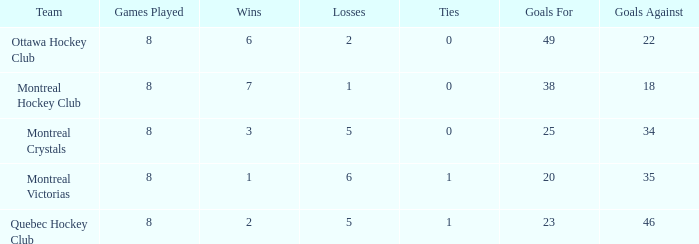What is the sum of the losses when the goals against is less than 34 and the games played is less than 8? None. 